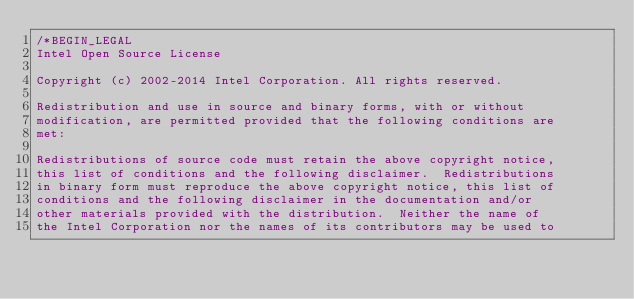Convert code to text. <code><loc_0><loc_0><loc_500><loc_500><_C++_>/*BEGIN_LEGAL 
Intel Open Source License 

Copyright (c) 2002-2014 Intel Corporation. All rights reserved.
 
Redistribution and use in source and binary forms, with or without
modification, are permitted provided that the following conditions are
met:

Redistributions of source code must retain the above copyright notice,
this list of conditions and the following disclaimer.  Redistributions
in binary form must reproduce the above copyright notice, this list of
conditions and the following disclaimer in the documentation and/or
other materials provided with the distribution.  Neither the name of
the Intel Corporation nor the names of its contributors may be used to</code> 